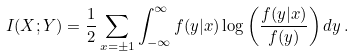Convert formula to latex. <formula><loc_0><loc_0><loc_500><loc_500>I ( X ; Y ) = \frac { 1 } { 2 } \sum _ { x = \pm 1 } \int _ { - \infty } ^ { \infty } f ( y | x ) \log \left ( \frac { f ( y | x ) } { f ( y ) } \right ) d y \, .</formula> 